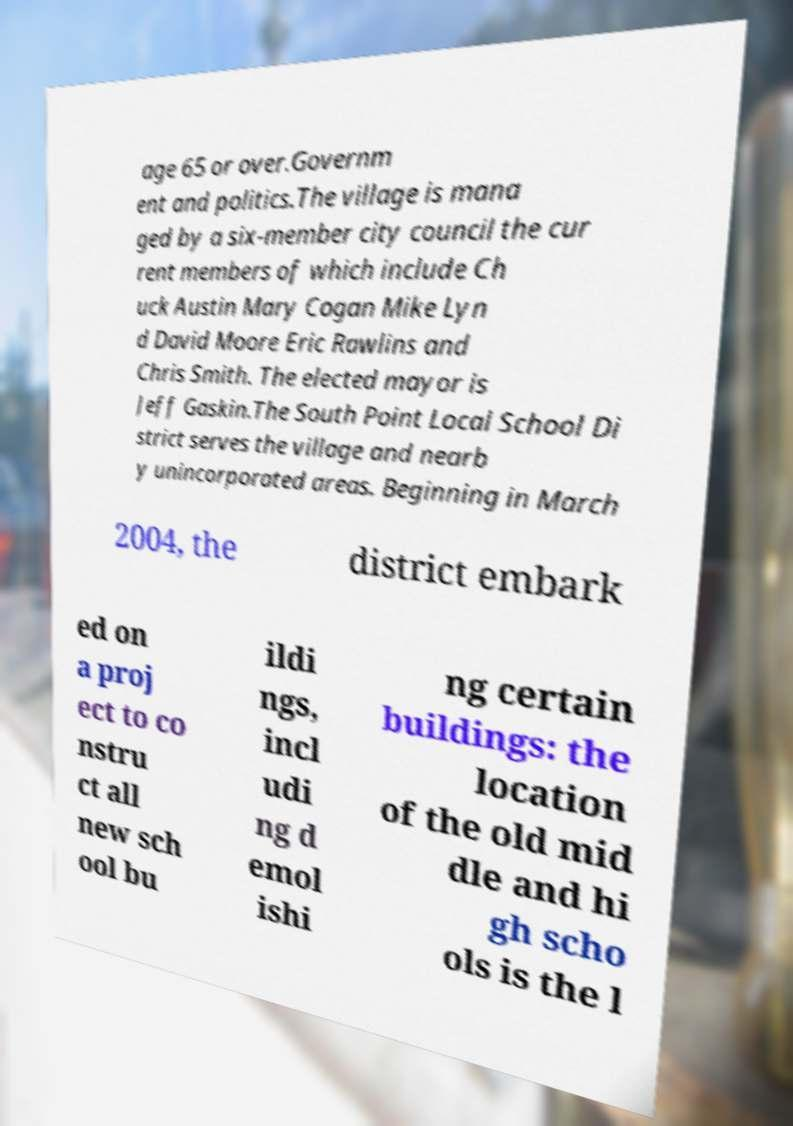Can you read and provide the text displayed in the image?This photo seems to have some interesting text. Can you extract and type it out for me? age 65 or over.Governm ent and politics.The village is mana ged by a six-member city council the cur rent members of which include Ch uck Austin Mary Cogan Mike Lyn d David Moore Eric Rawlins and Chris Smith. The elected mayor is Jeff Gaskin.The South Point Local School Di strict serves the village and nearb y unincorporated areas. Beginning in March 2004, the district embark ed on a proj ect to co nstru ct all new sch ool bu ildi ngs, incl udi ng d emol ishi ng certain buildings: the location of the old mid dle and hi gh scho ols is the l 